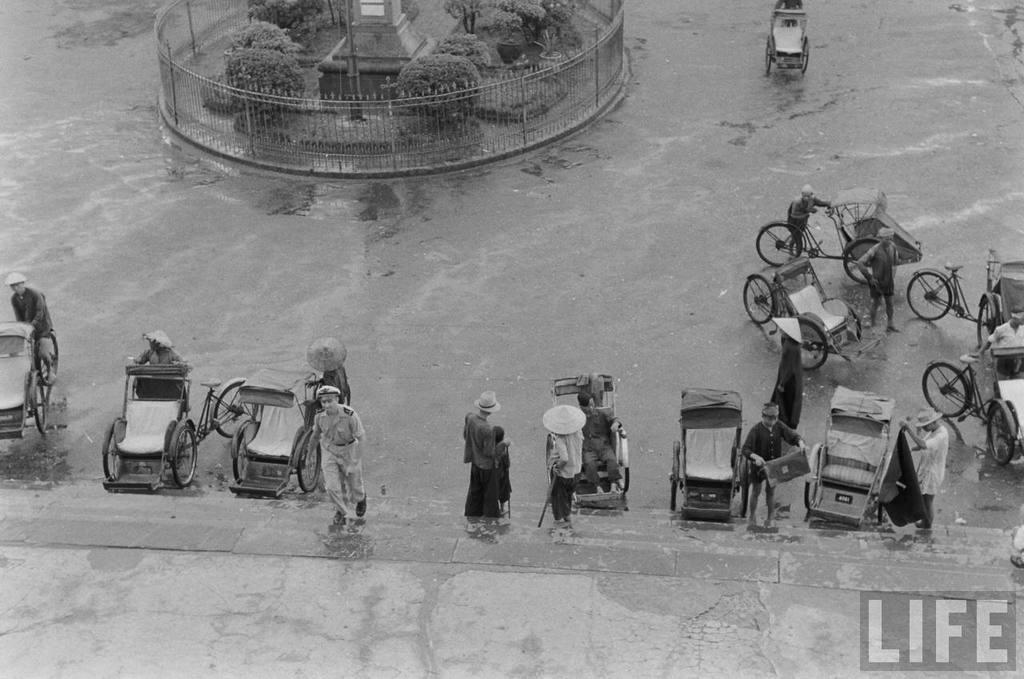In one or two sentences, can you explain what this image depicts? In the picture we can see a road with a water and a path and near to the path we can see some three wheeler s and some people with hats and on the road we can see a round railing in it we can see a structured pillar and some plants in it and outside the railing also we can see one three wheeler. 